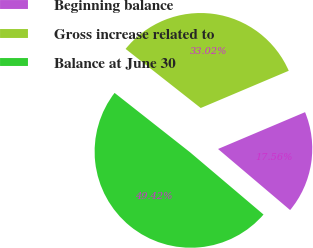<chart> <loc_0><loc_0><loc_500><loc_500><pie_chart><fcel>Beginning balance<fcel>Gross increase related to<fcel>Balance at June 30<nl><fcel>17.56%<fcel>33.02%<fcel>49.42%<nl></chart> 